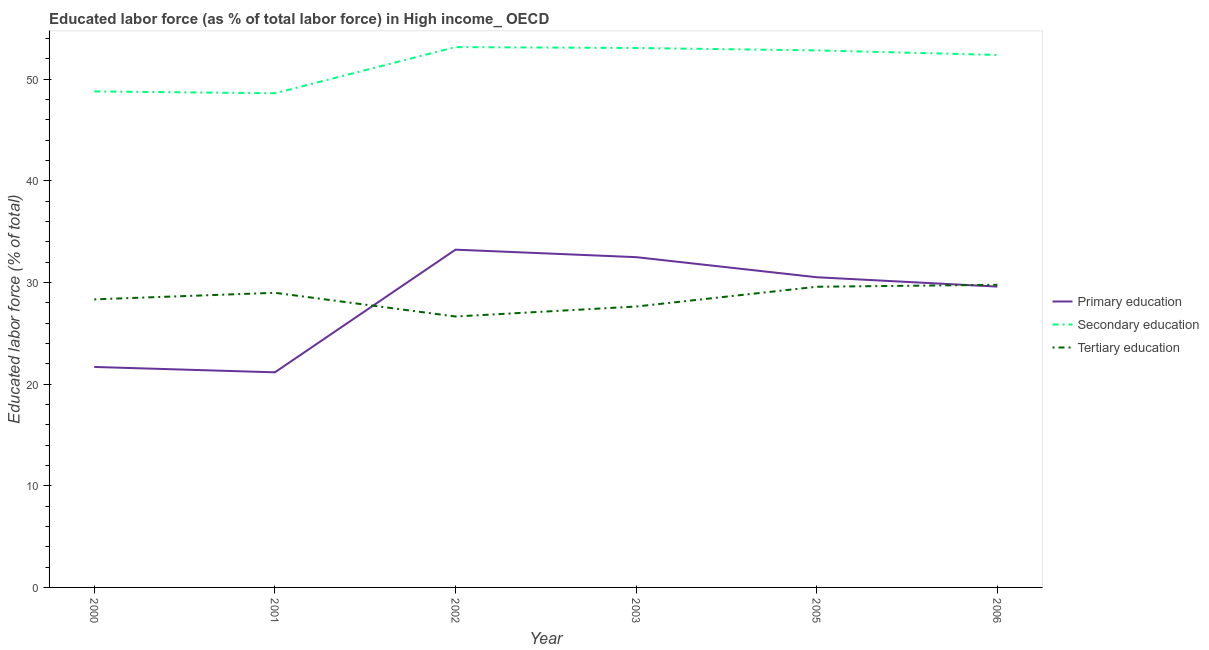How many different coloured lines are there?
Your answer should be compact. 3. What is the percentage of labor force who received primary education in 2000?
Your answer should be very brief. 21.69. Across all years, what is the maximum percentage of labor force who received tertiary education?
Keep it short and to the point. 29.77. Across all years, what is the minimum percentage of labor force who received primary education?
Give a very brief answer. 21.16. In which year was the percentage of labor force who received secondary education minimum?
Provide a short and direct response. 2001. What is the total percentage of labor force who received secondary education in the graph?
Your answer should be very brief. 308.84. What is the difference between the percentage of labor force who received primary education in 2001 and that in 2005?
Provide a succinct answer. -9.35. What is the difference between the percentage of labor force who received secondary education in 2006 and the percentage of labor force who received primary education in 2000?
Offer a terse response. 30.69. What is the average percentage of labor force who received tertiary education per year?
Provide a succinct answer. 28.49. In the year 2002, what is the difference between the percentage of labor force who received tertiary education and percentage of labor force who received secondary education?
Give a very brief answer. -26.5. What is the ratio of the percentage of labor force who received primary education in 2000 to that in 2001?
Your response must be concise. 1.02. What is the difference between the highest and the second highest percentage of labor force who received secondary education?
Offer a very short reply. 0.09. What is the difference between the highest and the lowest percentage of labor force who received secondary education?
Provide a succinct answer. 4.54. Is the sum of the percentage of labor force who received tertiary education in 2001 and 2006 greater than the maximum percentage of labor force who received primary education across all years?
Offer a very short reply. Yes. Does the percentage of labor force who received primary education monotonically increase over the years?
Your response must be concise. No. What is the difference between two consecutive major ticks on the Y-axis?
Ensure brevity in your answer.  10. Does the graph contain any zero values?
Your answer should be very brief. No. How many legend labels are there?
Provide a succinct answer. 3. What is the title of the graph?
Keep it short and to the point. Educated labor force (as % of total labor force) in High income_ OECD. What is the label or title of the X-axis?
Ensure brevity in your answer.  Year. What is the label or title of the Y-axis?
Provide a short and direct response. Educated labor force (% of total). What is the Educated labor force (% of total) in Primary education in 2000?
Offer a very short reply. 21.69. What is the Educated labor force (% of total) in Secondary education in 2000?
Provide a succinct answer. 48.8. What is the Educated labor force (% of total) of Tertiary education in 2000?
Your answer should be very brief. 28.34. What is the Educated labor force (% of total) of Primary education in 2001?
Make the answer very short. 21.16. What is the Educated labor force (% of total) in Secondary education in 2001?
Ensure brevity in your answer.  48.61. What is the Educated labor force (% of total) of Tertiary education in 2001?
Your response must be concise. 28.98. What is the Educated labor force (% of total) in Primary education in 2002?
Offer a very short reply. 33.23. What is the Educated labor force (% of total) of Secondary education in 2002?
Provide a short and direct response. 53.16. What is the Educated labor force (% of total) of Tertiary education in 2002?
Your response must be concise. 26.65. What is the Educated labor force (% of total) in Primary education in 2003?
Provide a succinct answer. 32.49. What is the Educated labor force (% of total) in Secondary education in 2003?
Keep it short and to the point. 53.07. What is the Educated labor force (% of total) of Tertiary education in 2003?
Give a very brief answer. 27.63. What is the Educated labor force (% of total) of Primary education in 2005?
Ensure brevity in your answer.  30.51. What is the Educated labor force (% of total) in Secondary education in 2005?
Provide a short and direct response. 52.83. What is the Educated labor force (% of total) in Tertiary education in 2005?
Your answer should be compact. 29.58. What is the Educated labor force (% of total) in Primary education in 2006?
Ensure brevity in your answer.  29.59. What is the Educated labor force (% of total) of Secondary education in 2006?
Keep it short and to the point. 52.38. What is the Educated labor force (% of total) of Tertiary education in 2006?
Your response must be concise. 29.77. Across all years, what is the maximum Educated labor force (% of total) in Primary education?
Provide a succinct answer. 33.23. Across all years, what is the maximum Educated labor force (% of total) of Secondary education?
Your answer should be very brief. 53.16. Across all years, what is the maximum Educated labor force (% of total) in Tertiary education?
Give a very brief answer. 29.77. Across all years, what is the minimum Educated labor force (% of total) in Primary education?
Keep it short and to the point. 21.16. Across all years, what is the minimum Educated labor force (% of total) in Secondary education?
Your answer should be compact. 48.61. Across all years, what is the minimum Educated labor force (% of total) in Tertiary education?
Offer a very short reply. 26.65. What is the total Educated labor force (% of total) in Primary education in the graph?
Give a very brief answer. 168.67. What is the total Educated labor force (% of total) of Secondary education in the graph?
Give a very brief answer. 308.84. What is the total Educated labor force (% of total) of Tertiary education in the graph?
Give a very brief answer. 170.96. What is the difference between the Educated labor force (% of total) in Primary education in 2000 and that in 2001?
Keep it short and to the point. 0.53. What is the difference between the Educated labor force (% of total) in Secondary education in 2000 and that in 2001?
Keep it short and to the point. 0.19. What is the difference between the Educated labor force (% of total) in Tertiary education in 2000 and that in 2001?
Keep it short and to the point. -0.65. What is the difference between the Educated labor force (% of total) in Primary education in 2000 and that in 2002?
Ensure brevity in your answer.  -11.54. What is the difference between the Educated labor force (% of total) in Secondary education in 2000 and that in 2002?
Your response must be concise. -4.36. What is the difference between the Educated labor force (% of total) of Tertiary education in 2000 and that in 2002?
Give a very brief answer. 1.69. What is the difference between the Educated labor force (% of total) of Primary education in 2000 and that in 2003?
Your answer should be compact. -10.8. What is the difference between the Educated labor force (% of total) in Secondary education in 2000 and that in 2003?
Provide a short and direct response. -4.27. What is the difference between the Educated labor force (% of total) in Tertiary education in 2000 and that in 2003?
Give a very brief answer. 0.7. What is the difference between the Educated labor force (% of total) in Primary education in 2000 and that in 2005?
Provide a succinct answer. -8.83. What is the difference between the Educated labor force (% of total) in Secondary education in 2000 and that in 2005?
Offer a terse response. -4.03. What is the difference between the Educated labor force (% of total) of Tertiary education in 2000 and that in 2005?
Make the answer very short. -1.24. What is the difference between the Educated labor force (% of total) in Primary education in 2000 and that in 2006?
Make the answer very short. -7.91. What is the difference between the Educated labor force (% of total) in Secondary education in 2000 and that in 2006?
Keep it short and to the point. -3.59. What is the difference between the Educated labor force (% of total) of Tertiary education in 2000 and that in 2006?
Offer a very short reply. -1.43. What is the difference between the Educated labor force (% of total) in Primary education in 2001 and that in 2002?
Provide a short and direct response. -12.07. What is the difference between the Educated labor force (% of total) of Secondary education in 2001 and that in 2002?
Keep it short and to the point. -4.54. What is the difference between the Educated labor force (% of total) of Tertiary education in 2001 and that in 2002?
Give a very brief answer. 2.33. What is the difference between the Educated labor force (% of total) of Primary education in 2001 and that in 2003?
Keep it short and to the point. -11.33. What is the difference between the Educated labor force (% of total) in Secondary education in 2001 and that in 2003?
Provide a short and direct response. -4.45. What is the difference between the Educated labor force (% of total) in Tertiary education in 2001 and that in 2003?
Give a very brief answer. 1.35. What is the difference between the Educated labor force (% of total) in Primary education in 2001 and that in 2005?
Offer a very short reply. -9.35. What is the difference between the Educated labor force (% of total) of Secondary education in 2001 and that in 2005?
Offer a terse response. -4.22. What is the difference between the Educated labor force (% of total) in Tertiary education in 2001 and that in 2005?
Your response must be concise. -0.59. What is the difference between the Educated labor force (% of total) of Primary education in 2001 and that in 2006?
Provide a succinct answer. -8.43. What is the difference between the Educated labor force (% of total) in Secondary education in 2001 and that in 2006?
Your answer should be very brief. -3.77. What is the difference between the Educated labor force (% of total) in Tertiary education in 2001 and that in 2006?
Keep it short and to the point. -0.79. What is the difference between the Educated labor force (% of total) in Primary education in 2002 and that in 2003?
Provide a succinct answer. 0.74. What is the difference between the Educated labor force (% of total) of Secondary education in 2002 and that in 2003?
Give a very brief answer. 0.09. What is the difference between the Educated labor force (% of total) of Tertiary education in 2002 and that in 2003?
Ensure brevity in your answer.  -0.98. What is the difference between the Educated labor force (% of total) in Primary education in 2002 and that in 2005?
Offer a terse response. 2.71. What is the difference between the Educated labor force (% of total) in Secondary education in 2002 and that in 2005?
Give a very brief answer. 0.33. What is the difference between the Educated labor force (% of total) of Tertiary education in 2002 and that in 2005?
Keep it short and to the point. -2.93. What is the difference between the Educated labor force (% of total) of Primary education in 2002 and that in 2006?
Ensure brevity in your answer.  3.63. What is the difference between the Educated labor force (% of total) in Secondary education in 2002 and that in 2006?
Provide a short and direct response. 0.77. What is the difference between the Educated labor force (% of total) of Tertiary education in 2002 and that in 2006?
Provide a short and direct response. -3.12. What is the difference between the Educated labor force (% of total) in Primary education in 2003 and that in 2005?
Offer a very short reply. 1.98. What is the difference between the Educated labor force (% of total) of Secondary education in 2003 and that in 2005?
Ensure brevity in your answer.  0.24. What is the difference between the Educated labor force (% of total) of Tertiary education in 2003 and that in 2005?
Provide a succinct answer. -1.94. What is the difference between the Educated labor force (% of total) in Primary education in 2003 and that in 2006?
Keep it short and to the point. 2.9. What is the difference between the Educated labor force (% of total) of Secondary education in 2003 and that in 2006?
Your answer should be very brief. 0.68. What is the difference between the Educated labor force (% of total) of Tertiary education in 2003 and that in 2006?
Offer a very short reply. -2.14. What is the difference between the Educated labor force (% of total) in Primary education in 2005 and that in 2006?
Provide a succinct answer. 0.92. What is the difference between the Educated labor force (% of total) in Secondary education in 2005 and that in 2006?
Offer a very short reply. 0.45. What is the difference between the Educated labor force (% of total) of Tertiary education in 2005 and that in 2006?
Your answer should be very brief. -0.19. What is the difference between the Educated labor force (% of total) in Primary education in 2000 and the Educated labor force (% of total) in Secondary education in 2001?
Provide a succinct answer. -26.92. What is the difference between the Educated labor force (% of total) of Primary education in 2000 and the Educated labor force (% of total) of Tertiary education in 2001?
Your answer should be compact. -7.3. What is the difference between the Educated labor force (% of total) of Secondary education in 2000 and the Educated labor force (% of total) of Tertiary education in 2001?
Make the answer very short. 19.81. What is the difference between the Educated labor force (% of total) in Primary education in 2000 and the Educated labor force (% of total) in Secondary education in 2002?
Make the answer very short. -31.47. What is the difference between the Educated labor force (% of total) of Primary education in 2000 and the Educated labor force (% of total) of Tertiary education in 2002?
Give a very brief answer. -4.96. What is the difference between the Educated labor force (% of total) in Secondary education in 2000 and the Educated labor force (% of total) in Tertiary education in 2002?
Offer a very short reply. 22.15. What is the difference between the Educated labor force (% of total) of Primary education in 2000 and the Educated labor force (% of total) of Secondary education in 2003?
Ensure brevity in your answer.  -31.38. What is the difference between the Educated labor force (% of total) of Primary education in 2000 and the Educated labor force (% of total) of Tertiary education in 2003?
Offer a terse response. -5.95. What is the difference between the Educated labor force (% of total) in Secondary education in 2000 and the Educated labor force (% of total) in Tertiary education in 2003?
Offer a very short reply. 21.16. What is the difference between the Educated labor force (% of total) of Primary education in 2000 and the Educated labor force (% of total) of Secondary education in 2005?
Provide a short and direct response. -31.14. What is the difference between the Educated labor force (% of total) of Primary education in 2000 and the Educated labor force (% of total) of Tertiary education in 2005?
Provide a short and direct response. -7.89. What is the difference between the Educated labor force (% of total) in Secondary education in 2000 and the Educated labor force (% of total) in Tertiary education in 2005?
Your answer should be compact. 19.22. What is the difference between the Educated labor force (% of total) in Primary education in 2000 and the Educated labor force (% of total) in Secondary education in 2006?
Provide a succinct answer. -30.69. What is the difference between the Educated labor force (% of total) of Primary education in 2000 and the Educated labor force (% of total) of Tertiary education in 2006?
Make the answer very short. -8.08. What is the difference between the Educated labor force (% of total) in Secondary education in 2000 and the Educated labor force (% of total) in Tertiary education in 2006?
Your answer should be compact. 19.03. What is the difference between the Educated labor force (% of total) of Primary education in 2001 and the Educated labor force (% of total) of Secondary education in 2002?
Give a very brief answer. -31.99. What is the difference between the Educated labor force (% of total) of Primary education in 2001 and the Educated labor force (% of total) of Tertiary education in 2002?
Give a very brief answer. -5.49. What is the difference between the Educated labor force (% of total) in Secondary education in 2001 and the Educated labor force (% of total) in Tertiary education in 2002?
Give a very brief answer. 21.96. What is the difference between the Educated labor force (% of total) of Primary education in 2001 and the Educated labor force (% of total) of Secondary education in 2003?
Give a very brief answer. -31.9. What is the difference between the Educated labor force (% of total) in Primary education in 2001 and the Educated labor force (% of total) in Tertiary education in 2003?
Provide a succinct answer. -6.47. What is the difference between the Educated labor force (% of total) in Secondary education in 2001 and the Educated labor force (% of total) in Tertiary education in 2003?
Offer a very short reply. 20.98. What is the difference between the Educated labor force (% of total) in Primary education in 2001 and the Educated labor force (% of total) in Secondary education in 2005?
Make the answer very short. -31.67. What is the difference between the Educated labor force (% of total) of Primary education in 2001 and the Educated labor force (% of total) of Tertiary education in 2005?
Your answer should be very brief. -8.42. What is the difference between the Educated labor force (% of total) of Secondary education in 2001 and the Educated labor force (% of total) of Tertiary education in 2005?
Your response must be concise. 19.03. What is the difference between the Educated labor force (% of total) of Primary education in 2001 and the Educated labor force (% of total) of Secondary education in 2006?
Ensure brevity in your answer.  -31.22. What is the difference between the Educated labor force (% of total) in Primary education in 2001 and the Educated labor force (% of total) in Tertiary education in 2006?
Your answer should be compact. -8.61. What is the difference between the Educated labor force (% of total) in Secondary education in 2001 and the Educated labor force (% of total) in Tertiary education in 2006?
Give a very brief answer. 18.84. What is the difference between the Educated labor force (% of total) of Primary education in 2002 and the Educated labor force (% of total) of Secondary education in 2003?
Give a very brief answer. -19.84. What is the difference between the Educated labor force (% of total) of Primary education in 2002 and the Educated labor force (% of total) of Tertiary education in 2003?
Ensure brevity in your answer.  5.59. What is the difference between the Educated labor force (% of total) of Secondary education in 2002 and the Educated labor force (% of total) of Tertiary education in 2003?
Offer a very short reply. 25.52. What is the difference between the Educated labor force (% of total) of Primary education in 2002 and the Educated labor force (% of total) of Secondary education in 2005?
Your response must be concise. -19.6. What is the difference between the Educated labor force (% of total) of Primary education in 2002 and the Educated labor force (% of total) of Tertiary education in 2005?
Make the answer very short. 3.65. What is the difference between the Educated labor force (% of total) in Secondary education in 2002 and the Educated labor force (% of total) in Tertiary education in 2005?
Offer a terse response. 23.58. What is the difference between the Educated labor force (% of total) of Primary education in 2002 and the Educated labor force (% of total) of Secondary education in 2006?
Your answer should be compact. -19.16. What is the difference between the Educated labor force (% of total) in Primary education in 2002 and the Educated labor force (% of total) in Tertiary education in 2006?
Your response must be concise. 3.46. What is the difference between the Educated labor force (% of total) in Secondary education in 2002 and the Educated labor force (% of total) in Tertiary education in 2006?
Your answer should be compact. 23.39. What is the difference between the Educated labor force (% of total) of Primary education in 2003 and the Educated labor force (% of total) of Secondary education in 2005?
Give a very brief answer. -20.34. What is the difference between the Educated labor force (% of total) of Primary education in 2003 and the Educated labor force (% of total) of Tertiary education in 2005?
Your answer should be compact. 2.91. What is the difference between the Educated labor force (% of total) of Secondary education in 2003 and the Educated labor force (% of total) of Tertiary education in 2005?
Give a very brief answer. 23.49. What is the difference between the Educated labor force (% of total) in Primary education in 2003 and the Educated labor force (% of total) in Secondary education in 2006?
Give a very brief answer. -19.89. What is the difference between the Educated labor force (% of total) of Primary education in 2003 and the Educated labor force (% of total) of Tertiary education in 2006?
Make the answer very short. 2.72. What is the difference between the Educated labor force (% of total) in Secondary education in 2003 and the Educated labor force (% of total) in Tertiary education in 2006?
Provide a succinct answer. 23.3. What is the difference between the Educated labor force (% of total) of Primary education in 2005 and the Educated labor force (% of total) of Secondary education in 2006?
Offer a terse response. -21.87. What is the difference between the Educated labor force (% of total) in Primary education in 2005 and the Educated labor force (% of total) in Tertiary education in 2006?
Your response must be concise. 0.74. What is the difference between the Educated labor force (% of total) in Secondary education in 2005 and the Educated labor force (% of total) in Tertiary education in 2006?
Provide a short and direct response. 23.06. What is the average Educated labor force (% of total) in Primary education per year?
Ensure brevity in your answer.  28.11. What is the average Educated labor force (% of total) in Secondary education per year?
Give a very brief answer. 51.47. What is the average Educated labor force (% of total) of Tertiary education per year?
Offer a very short reply. 28.49. In the year 2000, what is the difference between the Educated labor force (% of total) of Primary education and Educated labor force (% of total) of Secondary education?
Offer a terse response. -27.11. In the year 2000, what is the difference between the Educated labor force (% of total) of Primary education and Educated labor force (% of total) of Tertiary education?
Make the answer very short. -6.65. In the year 2000, what is the difference between the Educated labor force (% of total) of Secondary education and Educated labor force (% of total) of Tertiary education?
Provide a short and direct response. 20.46. In the year 2001, what is the difference between the Educated labor force (% of total) of Primary education and Educated labor force (% of total) of Secondary education?
Offer a very short reply. -27.45. In the year 2001, what is the difference between the Educated labor force (% of total) of Primary education and Educated labor force (% of total) of Tertiary education?
Ensure brevity in your answer.  -7.82. In the year 2001, what is the difference between the Educated labor force (% of total) in Secondary education and Educated labor force (% of total) in Tertiary education?
Your response must be concise. 19.63. In the year 2002, what is the difference between the Educated labor force (% of total) in Primary education and Educated labor force (% of total) in Secondary education?
Give a very brief answer. -19.93. In the year 2002, what is the difference between the Educated labor force (% of total) in Primary education and Educated labor force (% of total) in Tertiary education?
Ensure brevity in your answer.  6.58. In the year 2002, what is the difference between the Educated labor force (% of total) of Secondary education and Educated labor force (% of total) of Tertiary education?
Offer a terse response. 26.5. In the year 2003, what is the difference between the Educated labor force (% of total) in Primary education and Educated labor force (% of total) in Secondary education?
Make the answer very short. -20.57. In the year 2003, what is the difference between the Educated labor force (% of total) in Primary education and Educated labor force (% of total) in Tertiary education?
Offer a very short reply. 4.86. In the year 2003, what is the difference between the Educated labor force (% of total) in Secondary education and Educated labor force (% of total) in Tertiary education?
Your answer should be very brief. 25.43. In the year 2005, what is the difference between the Educated labor force (% of total) of Primary education and Educated labor force (% of total) of Secondary education?
Your response must be concise. -22.32. In the year 2005, what is the difference between the Educated labor force (% of total) of Primary education and Educated labor force (% of total) of Tertiary education?
Make the answer very short. 0.94. In the year 2005, what is the difference between the Educated labor force (% of total) of Secondary education and Educated labor force (% of total) of Tertiary education?
Offer a very short reply. 23.25. In the year 2006, what is the difference between the Educated labor force (% of total) in Primary education and Educated labor force (% of total) in Secondary education?
Offer a very short reply. -22.79. In the year 2006, what is the difference between the Educated labor force (% of total) in Primary education and Educated labor force (% of total) in Tertiary education?
Offer a terse response. -0.18. In the year 2006, what is the difference between the Educated labor force (% of total) of Secondary education and Educated labor force (% of total) of Tertiary education?
Give a very brief answer. 22.61. What is the ratio of the Educated labor force (% of total) in Primary education in 2000 to that in 2001?
Provide a short and direct response. 1.02. What is the ratio of the Educated labor force (% of total) in Secondary education in 2000 to that in 2001?
Provide a succinct answer. 1. What is the ratio of the Educated labor force (% of total) in Tertiary education in 2000 to that in 2001?
Offer a very short reply. 0.98. What is the ratio of the Educated labor force (% of total) of Primary education in 2000 to that in 2002?
Your answer should be very brief. 0.65. What is the ratio of the Educated labor force (% of total) in Secondary education in 2000 to that in 2002?
Give a very brief answer. 0.92. What is the ratio of the Educated labor force (% of total) in Tertiary education in 2000 to that in 2002?
Your response must be concise. 1.06. What is the ratio of the Educated labor force (% of total) in Primary education in 2000 to that in 2003?
Give a very brief answer. 0.67. What is the ratio of the Educated labor force (% of total) of Secondary education in 2000 to that in 2003?
Give a very brief answer. 0.92. What is the ratio of the Educated labor force (% of total) of Tertiary education in 2000 to that in 2003?
Provide a short and direct response. 1.03. What is the ratio of the Educated labor force (% of total) of Primary education in 2000 to that in 2005?
Give a very brief answer. 0.71. What is the ratio of the Educated labor force (% of total) in Secondary education in 2000 to that in 2005?
Make the answer very short. 0.92. What is the ratio of the Educated labor force (% of total) of Tertiary education in 2000 to that in 2005?
Provide a succinct answer. 0.96. What is the ratio of the Educated labor force (% of total) of Primary education in 2000 to that in 2006?
Your answer should be very brief. 0.73. What is the ratio of the Educated labor force (% of total) in Secondary education in 2000 to that in 2006?
Make the answer very short. 0.93. What is the ratio of the Educated labor force (% of total) in Tertiary education in 2000 to that in 2006?
Ensure brevity in your answer.  0.95. What is the ratio of the Educated labor force (% of total) of Primary education in 2001 to that in 2002?
Provide a short and direct response. 0.64. What is the ratio of the Educated labor force (% of total) of Secondary education in 2001 to that in 2002?
Provide a short and direct response. 0.91. What is the ratio of the Educated labor force (% of total) in Tertiary education in 2001 to that in 2002?
Your response must be concise. 1.09. What is the ratio of the Educated labor force (% of total) of Primary education in 2001 to that in 2003?
Keep it short and to the point. 0.65. What is the ratio of the Educated labor force (% of total) in Secondary education in 2001 to that in 2003?
Your answer should be compact. 0.92. What is the ratio of the Educated labor force (% of total) of Tertiary education in 2001 to that in 2003?
Your answer should be very brief. 1.05. What is the ratio of the Educated labor force (% of total) in Primary education in 2001 to that in 2005?
Ensure brevity in your answer.  0.69. What is the ratio of the Educated labor force (% of total) of Secondary education in 2001 to that in 2005?
Offer a very short reply. 0.92. What is the ratio of the Educated labor force (% of total) of Tertiary education in 2001 to that in 2005?
Offer a very short reply. 0.98. What is the ratio of the Educated labor force (% of total) in Primary education in 2001 to that in 2006?
Your response must be concise. 0.71. What is the ratio of the Educated labor force (% of total) of Secondary education in 2001 to that in 2006?
Offer a terse response. 0.93. What is the ratio of the Educated labor force (% of total) of Tertiary education in 2001 to that in 2006?
Provide a succinct answer. 0.97. What is the ratio of the Educated labor force (% of total) of Primary education in 2002 to that in 2003?
Provide a short and direct response. 1.02. What is the ratio of the Educated labor force (% of total) of Tertiary education in 2002 to that in 2003?
Make the answer very short. 0.96. What is the ratio of the Educated labor force (% of total) in Primary education in 2002 to that in 2005?
Provide a short and direct response. 1.09. What is the ratio of the Educated labor force (% of total) in Secondary education in 2002 to that in 2005?
Offer a very short reply. 1.01. What is the ratio of the Educated labor force (% of total) in Tertiary education in 2002 to that in 2005?
Provide a succinct answer. 0.9. What is the ratio of the Educated labor force (% of total) in Primary education in 2002 to that in 2006?
Your answer should be very brief. 1.12. What is the ratio of the Educated labor force (% of total) in Secondary education in 2002 to that in 2006?
Provide a short and direct response. 1.01. What is the ratio of the Educated labor force (% of total) in Tertiary education in 2002 to that in 2006?
Give a very brief answer. 0.9. What is the ratio of the Educated labor force (% of total) of Primary education in 2003 to that in 2005?
Your answer should be very brief. 1.06. What is the ratio of the Educated labor force (% of total) in Secondary education in 2003 to that in 2005?
Your answer should be very brief. 1. What is the ratio of the Educated labor force (% of total) in Tertiary education in 2003 to that in 2005?
Keep it short and to the point. 0.93. What is the ratio of the Educated labor force (% of total) of Primary education in 2003 to that in 2006?
Provide a succinct answer. 1.1. What is the ratio of the Educated labor force (% of total) in Tertiary education in 2003 to that in 2006?
Provide a succinct answer. 0.93. What is the ratio of the Educated labor force (% of total) in Primary education in 2005 to that in 2006?
Offer a terse response. 1.03. What is the ratio of the Educated labor force (% of total) in Secondary education in 2005 to that in 2006?
Provide a succinct answer. 1.01. What is the difference between the highest and the second highest Educated labor force (% of total) of Primary education?
Keep it short and to the point. 0.74. What is the difference between the highest and the second highest Educated labor force (% of total) of Secondary education?
Offer a very short reply. 0.09. What is the difference between the highest and the second highest Educated labor force (% of total) of Tertiary education?
Ensure brevity in your answer.  0.19. What is the difference between the highest and the lowest Educated labor force (% of total) of Primary education?
Offer a very short reply. 12.07. What is the difference between the highest and the lowest Educated labor force (% of total) of Secondary education?
Your answer should be compact. 4.54. What is the difference between the highest and the lowest Educated labor force (% of total) in Tertiary education?
Offer a very short reply. 3.12. 